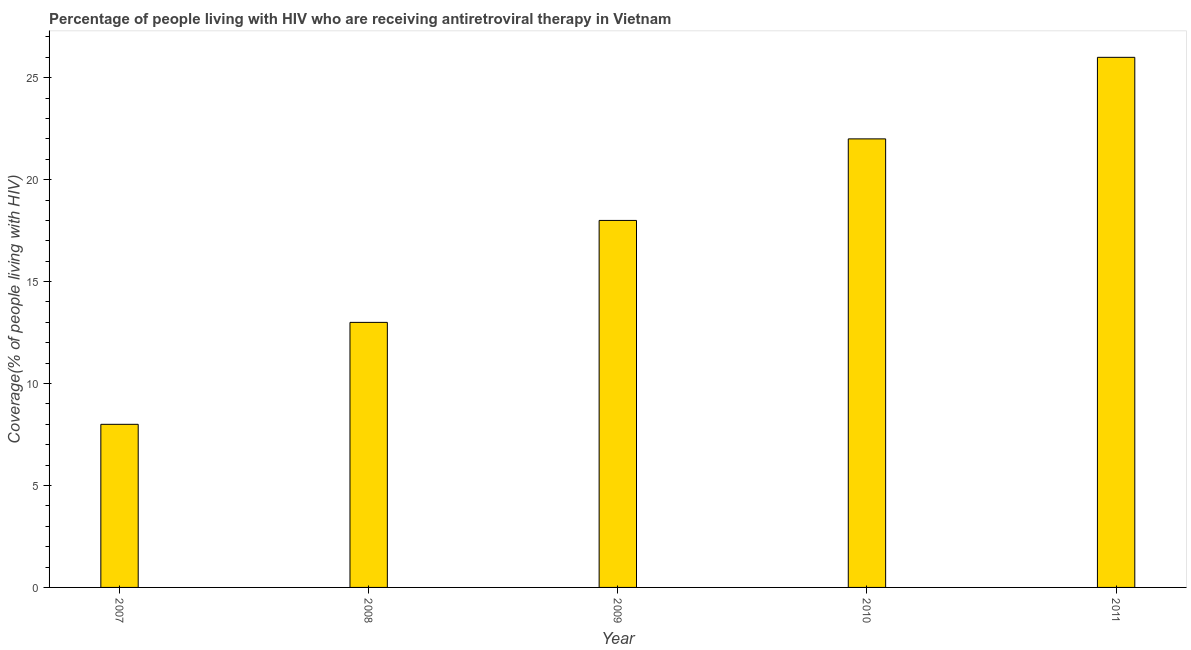What is the title of the graph?
Your answer should be compact. Percentage of people living with HIV who are receiving antiretroviral therapy in Vietnam. What is the label or title of the X-axis?
Keep it short and to the point. Year. What is the label or title of the Y-axis?
Give a very brief answer. Coverage(% of people living with HIV). What is the antiretroviral therapy coverage in 2010?
Give a very brief answer. 22. Across all years, what is the minimum antiretroviral therapy coverage?
Give a very brief answer. 8. In which year was the antiretroviral therapy coverage minimum?
Keep it short and to the point. 2007. What is the difference between the antiretroviral therapy coverage in 2008 and 2011?
Give a very brief answer. -13. What is the median antiretroviral therapy coverage?
Your response must be concise. 18. In how many years, is the antiretroviral therapy coverage greater than 25 %?
Keep it short and to the point. 1. Do a majority of the years between 2009 and 2010 (inclusive) have antiretroviral therapy coverage greater than 2 %?
Keep it short and to the point. Yes. What is the ratio of the antiretroviral therapy coverage in 2009 to that in 2010?
Your response must be concise. 0.82. Is the sum of the antiretroviral therapy coverage in 2009 and 2010 greater than the maximum antiretroviral therapy coverage across all years?
Keep it short and to the point. Yes. What is the difference between the highest and the lowest antiretroviral therapy coverage?
Provide a short and direct response. 18. How many years are there in the graph?
Offer a very short reply. 5. What is the difference between two consecutive major ticks on the Y-axis?
Your answer should be compact. 5. What is the Coverage(% of people living with HIV) of 2007?
Make the answer very short. 8. What is the Coverage(% of people living with HIV) of 2009?
Your answer should be very brief. 18. What is the difference between the Coverage(% of people living with HIV) in 2007 and 2009?
Keep it short and to the point. -10. What is the difference between the Coverage(% of people living with HIV) in 2007 and 2010?
Ensure brevity in your answer.  -14. What is the difference between the Coverage(% of people living with HIV) in 2007 and 2011?
Your response must be concise. -18. What is the difference between the Coverage(% of people living with HIV) in 2008 and 2011?
Keep it short and to the point. -13. What is the difference between the Coverage(% of people living with HIV) in 2009 and 2010?
Provide a short and direct response. -4. What is the difference between the Coverage(% of people living with HIV) in 2010 and 2011?
Give a very brief answer. -4. What is the ratio of the Coverage(% of people living with HIV) in 2007 to that in 2008?
Your response must be concise. 0.61. What is the ratio of the Coverage(% of people living with HIV) in 2007 to that in 2009?
Make the answer very short. 0.44. What is the ratio of the Coverage(% of people living with HIV) in 2007 to that in 2010?
Provide a succinct answer. 0.36. What is the ratio of the Coverage(% of people living with HIV) in 2007 to that in 2011?
Your answer should be very brief. 0.31. What is the ratio of the Coverage(% of people living with HIV) in 2008 to that in 2009?
Offer a very short reply. 0.72. What is the ratio of the Coverage(% of people living with HIV) in 2008 to that in 2010?
Provide a succinct answer. 0.59. What is the ratio of the Coverage(% of people living with HIV) in 2008 to that in 2011?
Your answer should be very brief. 0.5. What is the ratio of the Coverage(% of people living with HIV) in 2009 to that in 2010?
Give a very brief answer. 0.82. What is the ratio of the Coverage(% of people living with HIV) in 2009 to that in 2011?
Your response must be concise. 0.69. What is the ratio of the Coverage(% of people living with HIV) in 2010 to that in 2011?
Your answer should be compact. 0.85. 